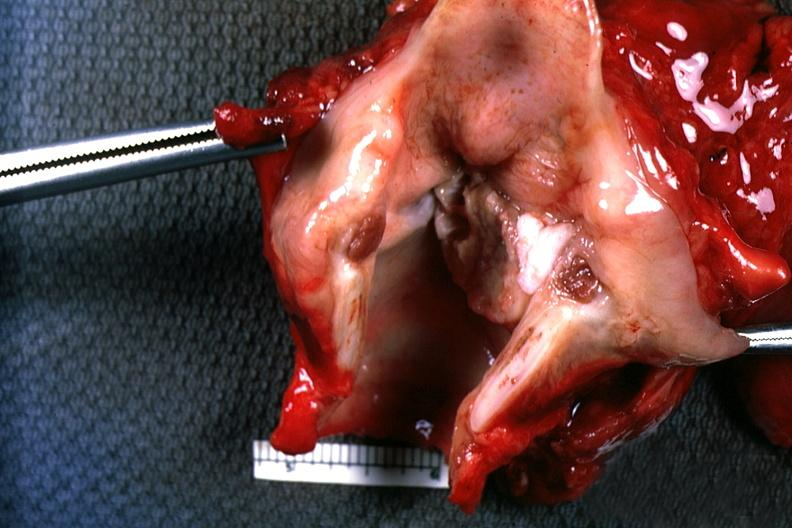where is this?
Answer the question using a single word or phrase. Oral 